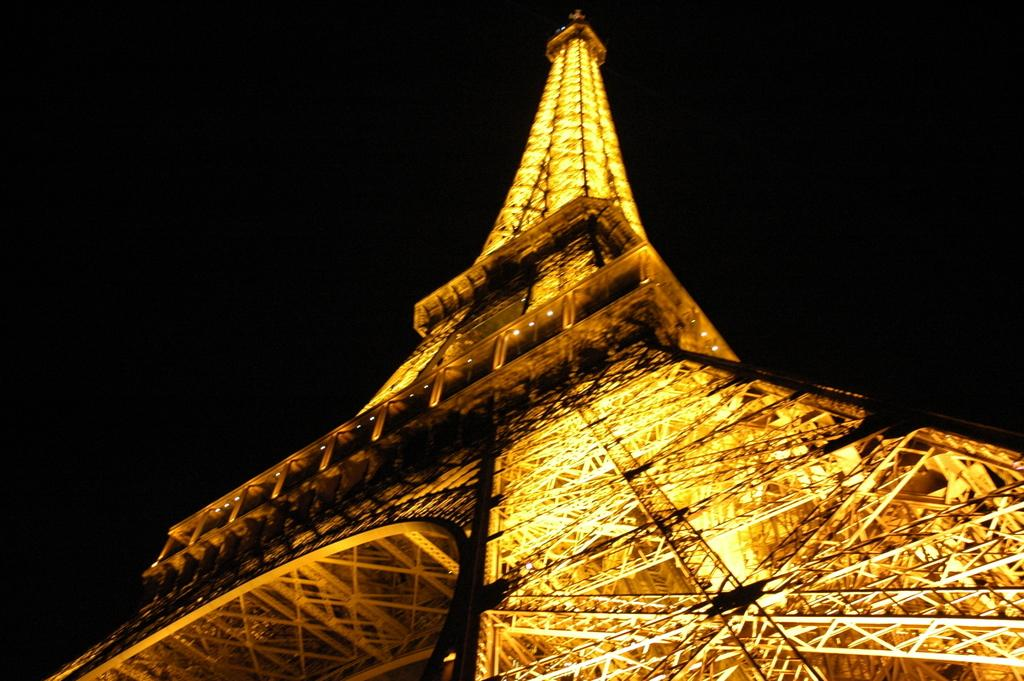What famous landmark can be seen in the image? The Eiffel Tower is present in the image. What can be observed about the lighting in the image? There are lights visible in the image. What type of corn is being harvested in the image? There is no corn present in the image; it features the Eiffel Tower and lights. How does the Eiffel Tower show respect to the people in the image? The Eiffel Tower is an inanimate object and does not have the ability to show respect. 